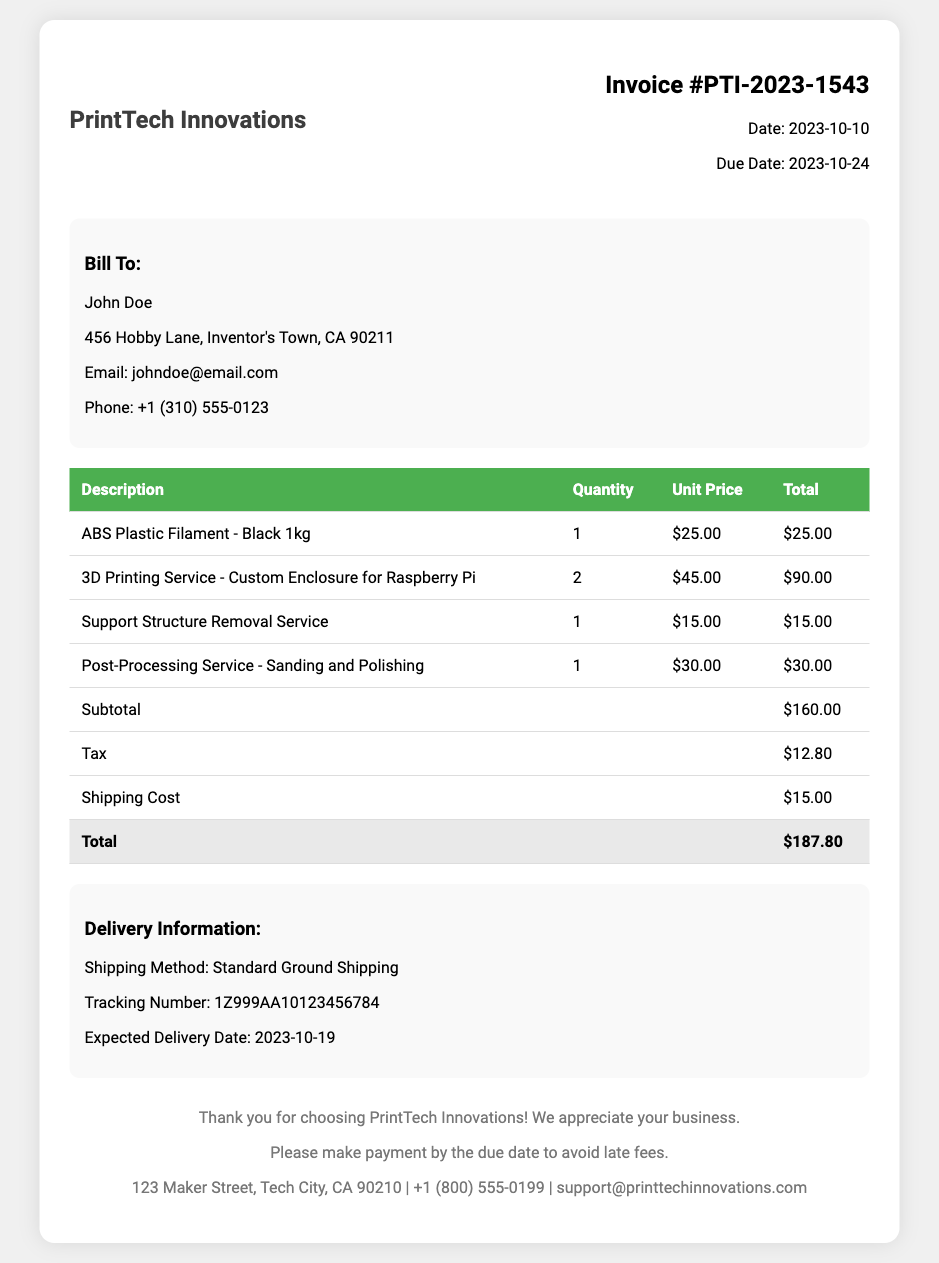What is the invoice number? The invoice number is displayed prominently in the header section of the document.
Answer: PTI-2023-1543 Who is the invoice billed to? The name of the person the invoice is billed to is found in the customer details section.
Answer: John Doe What is the due date for this invoice? The due date is mentioned alongside the invoice number and date in the invoice details section.
Answer: 2023-10-24 What is the total amount of the invoice? The total amount is calculated from the subtotal, tax, and shipping cost, listed at the bottom of the table.
Answer: $187.80 What is the expected delivery date? The expected delivery date is stated in the delivery information section of the document.
Answer: 2023-10-19 How many 3D printing services for the custom enclosure were ordered? The quantity of services ordered is provided in the itemized costs table for the specific service.
Answer: 2 What is the shipping method used? The shipping method is given in the delivery information section of the document.
Answer: Standard Ground Shipping What is the tracking number? The tracking number is specified in the delivery information section, which links to the shipping details.
Answer: 1Z999AA10123456784 What services were included in the post-processing? The post-processing service description is available in the itemized costs table.
Answer: Sanding and Polishing 